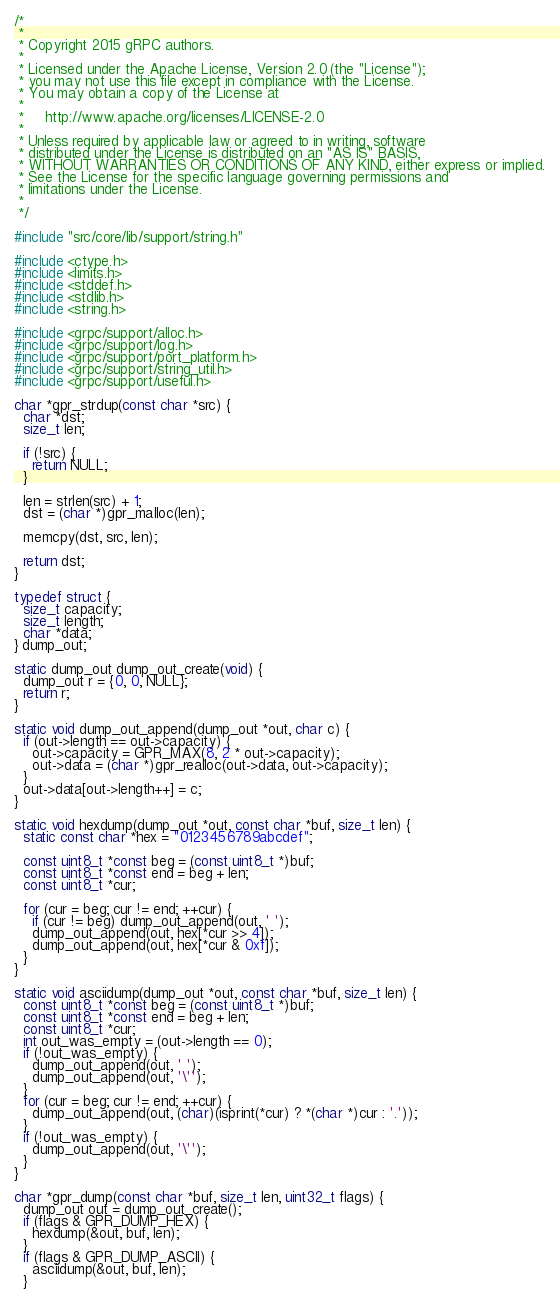Convert code to text. <code><loc_0><loc_0><loc_500><loc_500><_C++_>/*
 *
 * Copyright 2015 gRPC authors.
 *
 * Licensed under the Apache License, Version 2.0 (the "License");
 * you may not use this file except in compliance with the License.
 * You may obtain a copy of the License at
 *
 *     http://www.apache.org/licenses/LICENSE-2.0
 *
 * Unless required by applicable law or agreed to in writing, software
 * distributed under the License is distributed on an "AS IS" BASIS,
 * WITHOUT WARRANTIES OR CONDITIONS OF ANY KIND, either express or implied.
 * See the License for the specific language governing permissions and
 * limitations under the License.
 *
 */

#include "src/core/lib/support/string.h"

#include <ctype.h>
#include <limits.h>
#include <stddef.h>
#include <stdlib.h>
#include <string.h>

#include <grpc/support/alloc.h>
#include <grpc/support/log.h>
#include <grpc/support/port_platform.h>
#include <grpc/support/string_util.h>
#include <grpc/support/useful.h>

char *gpr_strdup(const char *src) {
  char *dst;
  size_t len;

  if (!src) {
    return NULL;
  }

  len = strlen(src) + 1;
  dst = (char *)gpr_malloc(len);

  memcpy(dst, src, len);

  return dst;
}

typedef struct {
  size_t capacity;
  size_t length;
  char *data;
} dump_out;

static dump_out dump_out_create(void) {
  dump_out r = {0, 0, NULL};
  return r;
}

static void dump_out_append(dump_out *out, char c) {
  if (out->length == out->capacity) {
    out->capacity = GPR_MAX(8, 2 * out->capacity);
    out->data = (char *)gpr_realloc(out->data, out->capacity);
  }
  out->data[out->length++] = c;
}

static void hexdump(dump_out *out, const char *buf, size_t len) {
  static const char *hex = "0123456789abcdef";

  const uint8_t *const beg = (const uint8_t *)buf;
  const uint8_t *const end = beg + len;
  const uint8_t *cur;

  for (cur = beg; cur != end; ++cur) {
    if (cur != beg) dump_out_append(out, ' ');
    dump_out_append(out, hex[*cur >> 4]);
    dump_out_append(out, hex[*cur & 0xf]);
  }
}

static void asciidump(dump_out *out, const char *buf, size_t len) {
  const uint8_t *const beg = (const uint8_t *)buf;
  const uint8_t *const end = beg + len;
  const uint8_t *cur;
  int out_was_empty = (out->length == 0);
  if (!out_was_empty) {
    dump_out_append(out, ' ');
    dump_out_append(out, '\'');
  }
  for (cur = beg; cur != end; ++cur) {
    dump_out_append(out, (char)(isprint(*cur) ? *(char *)cur : '.'));
  }
  if (!out_was_empty) {
    dump_out_append(out, '\'');
  }
}

char *gpr_dump(const char *buf, size_t len, uint32_t flags) {
  dump_out out = dump_out_create();
  if (flags & GPR_DUMP_HEX) {
    hexdump(&out, buf, len);
  }
  if (flags & GPR_DUMP_ASCII) {
    asciidump(&out, buf, len);
  }</code> 